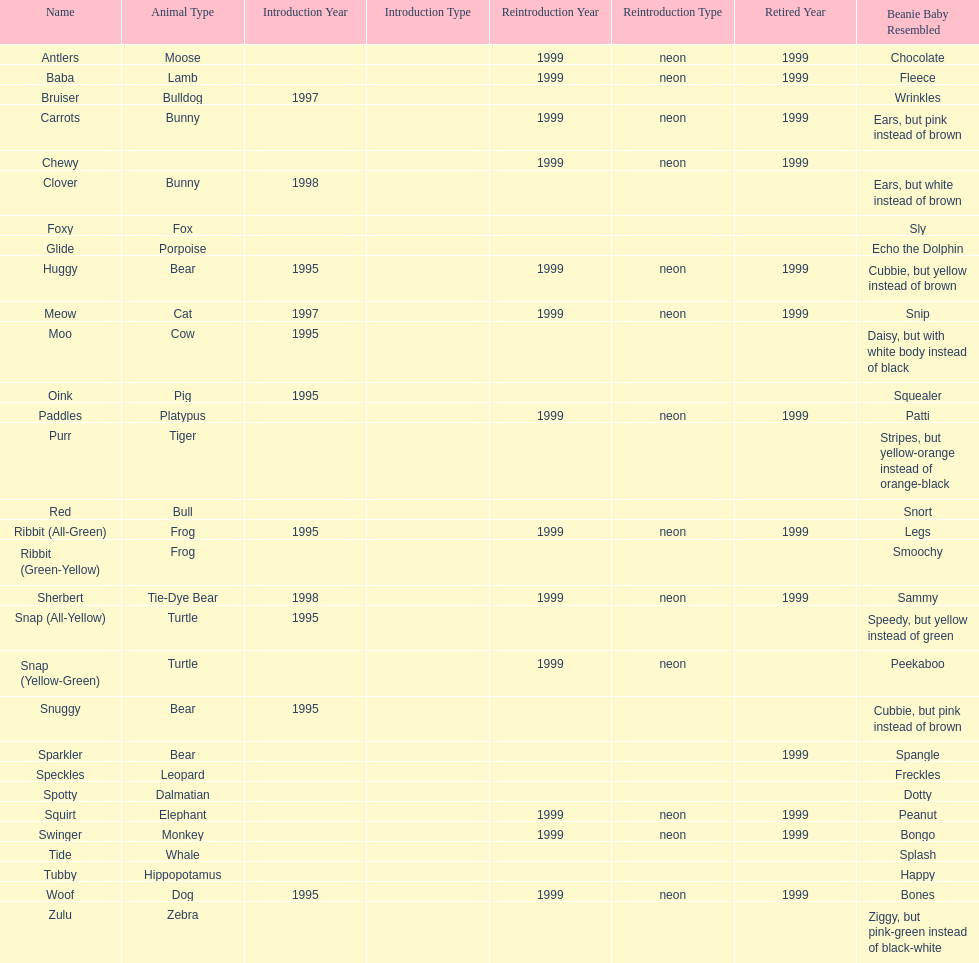How long was woof the dog sold before it was retired? 4 years. 